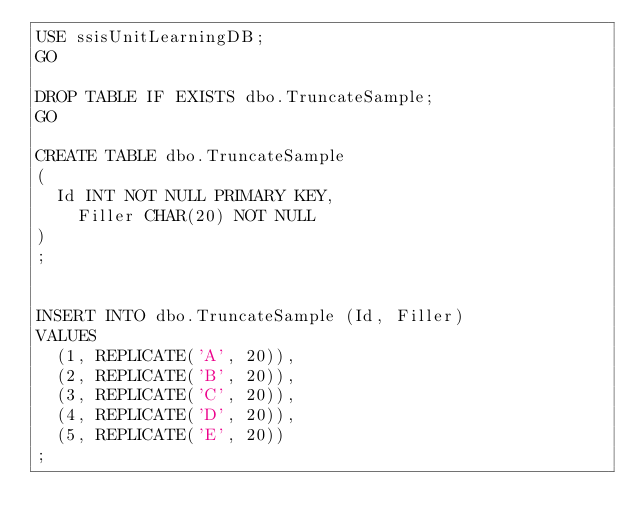Convert code to text. <code><loc_0><loc_0><loc_500><loc_500><_SQL_>USE ssisUnitLearningDB;
GO

DROP TABLE IF EXISTS dbo.TruncateSample;
GO

CREATE TABLE dbo.TruncateSample
(
	Id INT NOT NULL PRIMARY KEY, 
    Filler CHAR(20) NOT NULL
)
;


INSERT INTO dbo.TruncateSample (Id, Filler)
VALUES
	(1, REPLICATE('A', 20)),
	(2, REPLICATE('B', 20)),
	(3, REPLICATE('C', 20)),
	(4, REPLICATE('D', 20)),
	(5, REPLICATE('E', 20))
;</code> 